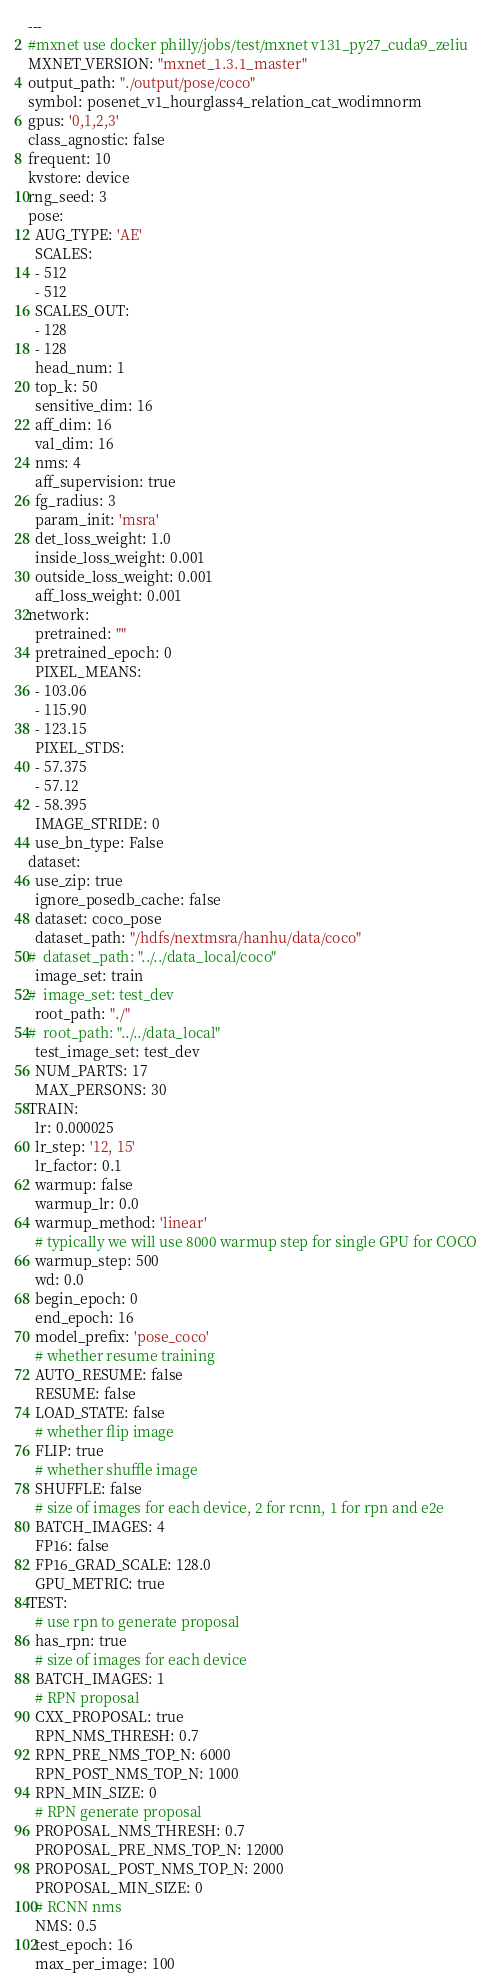<code> <loc_0><loc_0><loc_500><loc_500><_YAML_>---
#mxnet use docker philly/jobs/test/mxnet v131_py27_cuda9_zeliu
MXNET_VERSION: "mxnet_1.3.1_master"
output_path: "./output/pose/coco"
symbol: posenet_v1_hourglass4_relation_cat_wodimnorm
gpus: '0,1,2,3'
class_agnostic: false
frequent: 10
kvstore: device
rng_seed: 3
pose:
  AUG_TYPE: 'AE'
  SCALES:
  - 512
  - 512
  SCALES_OUT:
  - 128
  - 128
  head_num: 1
  top_k: 50
  sensitive_dim: 16
  aff_dim: 16
  val_dim: 16
  nms: 4
  aff_supervision: true
  fg_radius: 3
  param_init: 'msra'
  det_loss_weight: 1.0
  inside_loss_weight: 0.001
  outside_loss_weight: 0.001
  aff_loss_weight: 0.001
network:
  pretrained: ""
  pretrained_epoch: 0
  PIXEL_MEANS:
  - 103.06
  - 115.90
  - 123.15
  PIXEL_STDS:
  - 57.375
  - 57.12
  - 58.395
  IMAGE_STRIDE: 0
  use_bn_type: False
dataset:
  use_zip: true
  ignore_posedb_cache: false
  dataset: coco_pose
  dataset_path: "/hdfs/nextmsra/hanhu/data/coco"
#  dataset_path: "../../data_local/coco"
  image_set: train
#  image_set: test_dev
  root_path: "./"
#  root_path: "../../data_local"
  test_image_set: test_dev
  NUM_PARTS: 17
  MAX_PERSONS: 30
TRAIN:
  lr: 0.000025
  lr_step: '12, 15'
  lr_factor: 0.1
  warmup: false
  warmup_lr: 0.0
  warmup_method: 'linear'
  # typically we will use 8000 warmup step for single GPU for COCO
  warmup_step: 500
  wd: 0.0
  begin_epoch: 0
  end_epoch: 16
  model_prefix: 'pose_coco'
  # whether resume training
  AUTO_RESUME: false
  RESUME: false
  LOAD_STATE: false
  # whether flip image
  FLIP: true
  # whether shuffle image
  SHUFFLE: false
  # size of images for each device, 2 for rcnn, 1 for rpn and e2e
  BATCH_IMAGES: 4
  FP16: false
  FP16_GRAD_SCALE: 128.0
  GPU_METRIC: true
TEST:
  # use rpn to generate proposal
  has_rpn: true
  # size of images for each device
  BATCH_IMAGES: 1
  # RPN proposal
  CXX_PROPOSAL: true
  RPN_NMS_THRESH: 0.7
  RPN_PRE_NMS_TOP_N: 6000
  RPN_POST_NMS_TOP_N: 1000
  RPN_MIN_SIZE: 0
  # RPN generate proposal
  PROPOSAL_NMS_THRESH: 0.7
  PROPOSAL_PRE_NMS_TOP_N: 12000
  PROPOSAL_POST_NMS_TOP_N: 2000
  PROPOSAL_MIN_SIZE: 0
  # RCNN nms
  NMS: 0.5
  test_epoch: 16
  max_per_image: 100
</code> 